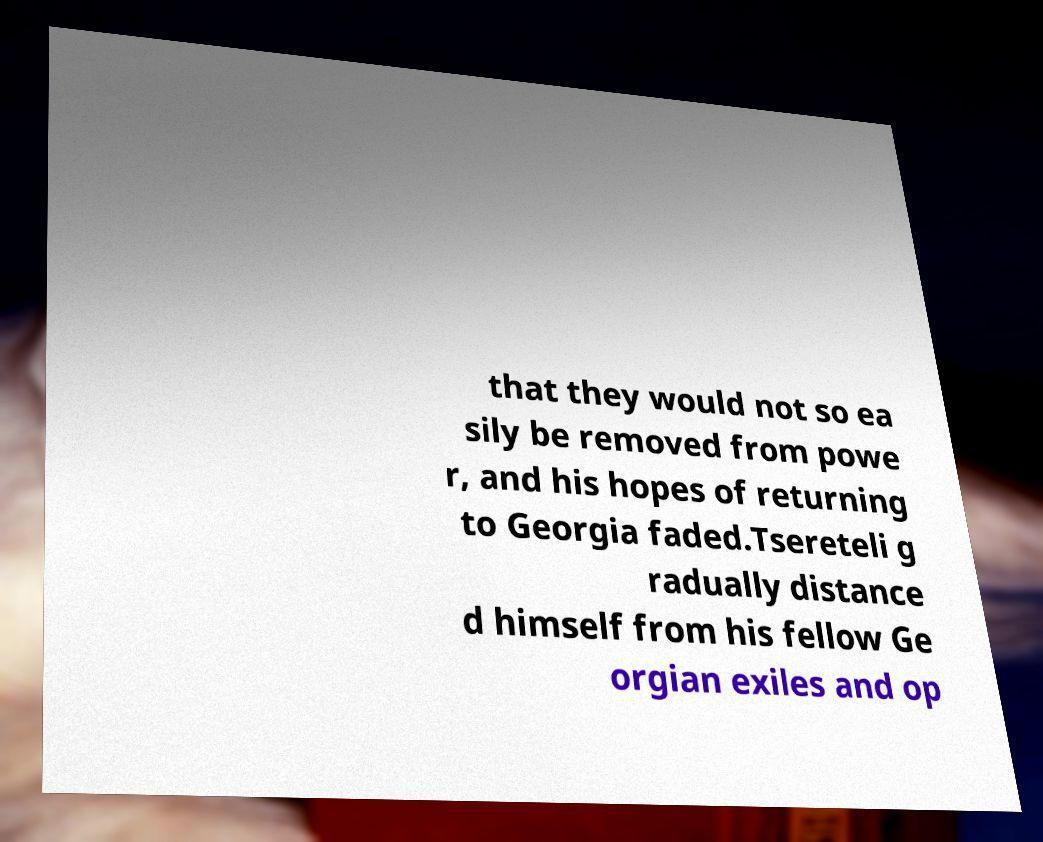Can you read and provide the text displayed in the image?This photo seems to have some interesting text. Can you extract and type it out for me? that they would not so ea sily be removed from powe r, and his hopes of returning to Georgia faded.Tsereteli g radually distance d himself from his fellow Ge orgian exiles and op 